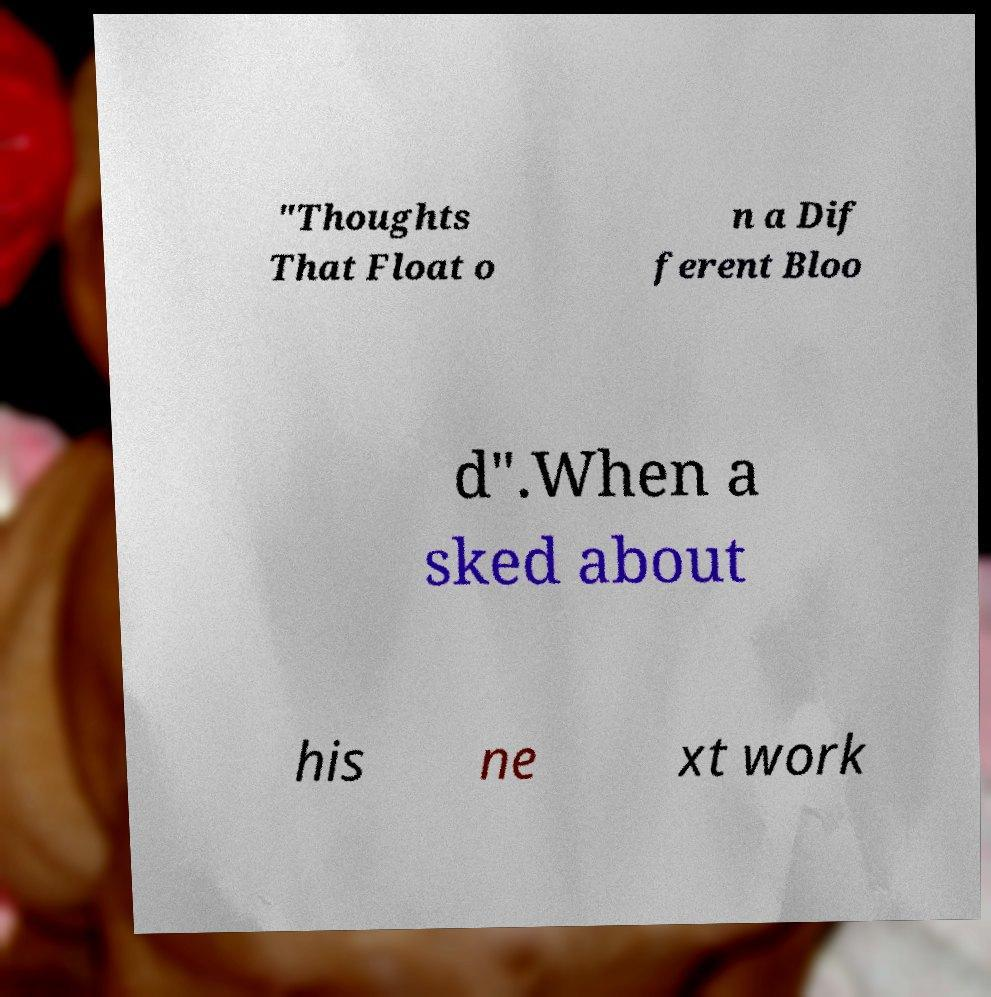Can you read and provide the text displayed in the image?This photo seems to have some interesting text. Can you extract and type it out for me? "Thoughts That Float o n a Dif ferent Bloo d".When a sked about his ne xt work 